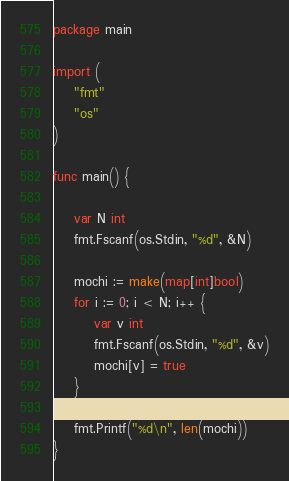<code> <loc_0><loc_0><loc_500><loc_500><_Go_>package main

import (
    "fmt"
    "os"
)

func main() {

    var N int
    fmt.Fscanf(os.Stdin, "%d", &N)

    mochi := make(map[int]bool)
    for i := 0; i < N; i++ {
        var v int
        fmt.Fscanf(os.Stdin, "%d", &v)
        mochi[v] = true
    }

    fmt.Printf("%d\n", len(mochi))
}</code> 